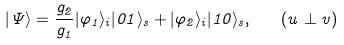<formula> <loc_0><loc_0><loc_500><loc_500>| \Psi \rangle = \frac { g _ { 2 } } { g _ { 1 } } | \varphi _ { 1 } \rangle _ { i } | 0 1 \rangle _ { s } + | \varphi _ { 2 } \rangle _ { i } | 1 0 \rangle _ { s } , \quad ( { u } \perp { v } )</formula> 